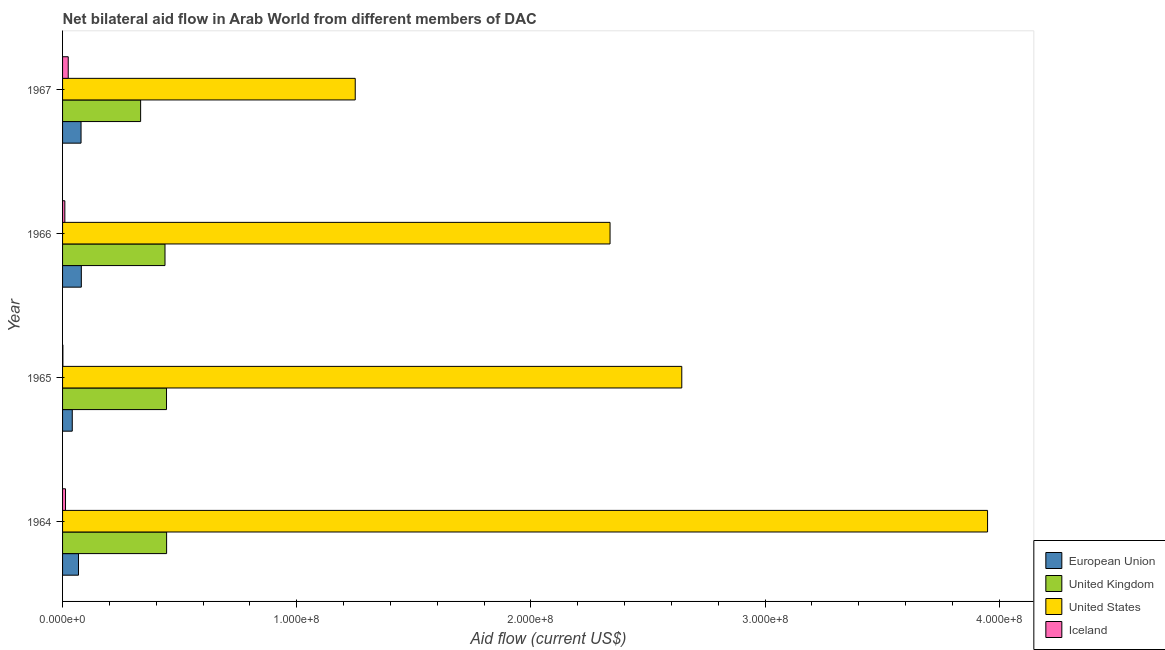How many groups of bars are there?
Ensure brevity in your answer.  4. How many bars are there on the 1st tick from the top?
Your answer should be very brief. 4. How many bars are there on the 2nd tick from the bottom?
Offer a very short reply. 4. What is the label of the 1st group of bars from the top?
Your answer should be compact. 1967. What is the amount of aid given by us in 1967?
Your answer should be compact. 1.25e+08. Across all years, what is the maximum amount of aid given by eu?
Provide a short and direct response. 8.01e+06. Across all years, what is the minimum amount of aid given by uk?
Offer a very short reply. 3.33e+07. In which year was the amount of aid given by iceland maximum?
Make the answer very short. 1967. In which year was the amount of aid given by iceland minimum?
Give a very brief answer. 1965. What is the total amount of aid given by eu in the graph?
Offer a terse response. 2.68e+07. What is the difference between the amount of aid given by uk in 1964 and that in 1967?
Offer a terse response. 1.11e+07. What is the difference between the amount of aid given by iceland in 1965 and the amount of aid given by eu in 1964?
Keep it short and to the point. -6.66e+06. What is the average amount of aid given by uk per year?
Provide a short and direct response. 4.15e+07. In the year 1967, what is the difference between the amount of aid given by eu and amount of aid given by us?
Offer a very short reply. -1.17e+08. In how many years, is the amount of aid given by us greater than 60000000 US$?
Your response must be concise. 4. What is the ratio of the amount of aid given by eu in 1965 to that in 1967?
Ensure brevity in your answer.  0.53. Is the amount of aid given by uk in 1964 less than that in 1965?
Your response must be concise. No. Is the difference between the amount of aid given by eu in 1964 and 1965 greater than the difference between the amount of aid given by uk in 1964 and 1965?
Keep it short and to the point. Yes. What is the difference between the highest and the second highest amount of aid given by us?
Ensure brevity in your answer.  1.31e+08. What is the difference between the highest and the lowest amount of aid given by iceland?
Your answer should be very brief. 2.28e+06. In how many years, is the amount of aid given by iceland greater than the average amount of aid given by iceland taken over all years?
Ensure brevity in your answer.  2. Is it the case that in every year, the sum of the amount of aid given by us and amount of aid given by uk is greater than the sum of amount of aid given by eu and amount of aid given by iceland?
Your answer should be compact. Yes. What does the 1st bar from the top in 1965 represents?
Provide a succinct answer. Iceland. How many bars are there?
Offer a terse response. 16. How many years are there in the graph?
Keep it short and to the point. 4. What is the difference between two consecutive major ticks on the X-axis?
Your answer should be very brief. 1.00e+08. Are the values on the major ticks of X-axis written in scientific E-notation?
Provide a succinct answer. Yes. Does the graph contain any zero values?
Offer a very short reply. No. Where does the legend appear in the graph?
Offer a terse response. Bottom right. How are the legend labels stacked?
Provide a short and direct response. Vertical. What is the title of the graph?
Provide a succinct answer. Net bilateral aid flow in Arab World from different members of DAC. What is the label or title of the Y-axis?
Give a very brief answer. Year. What is the Aid flow (current US$) of European Union in 1964?
Keep it short and to the point. 6.80e+06. What is the Aid flow (current US$) of United Kingdom in 1964?
Your answer should be compact. 4.44e+07. What is the Aid flow (current US$) in United States in 1964?
Make the answer very short. 3.95e+08. What is the Aid flow (current US$) in Iceland in 1964?
Offer a terse response. 1.26e+06. What is the Aid flow (current US$) in European Union in 1965?
Offer a terse response. 4.14e+06. What is the Aid flow (current US$) of United Kingdom in 1965?
Offer a very short reply. 4.44e+07. What is the Aid flow (current US$) in United States in 1965?
Your response must be concise. 2.64e+08. What is the Aid flow (current US$) of European Union in 1966?
Make the answer very short. 8.01e+06. What is the Aid flow (current US$) of United Kingdom in 1966?
Offer a terse response. 4.37e+07. What is the Aid flow (current US$) in United States in 1966?
Provide a short and direct response. 2.34e+08. What is the Aid flow (current US$) of Iceland in 1966?
Make the answer very short. 9.70e+05. What is the Aid flow (current US$) in European Union in 1967?
Your answer should be compact. 7.89e+06. What is the Aid flow (current US$) in United Kingdom in 1967?
Offer a very short reply. 3.33e+07. What is the Aid flow (current US$) in United States in 1967?
Make the answer very short. 1.25e+08. What is the Aid flow (current US$) of Iceland in 1967?
Provide a short and direct response. 2.42e+06. Across all years, what is the maximum Aid flow (current US$) of European Union?
Offer a very short reply. 8.01e+06. Across all years, what is the maximum Aid flow (current US$) in United Kingdom?
Give a very brief answer. 4.44e+07. Across all years, what is the maximum Aid flow (current US$) in United States?
Offer a very short reply. 3.95e+08. Across all years, what is the maximum Aid flow (current US$) of Iceland?
Offer a terse response. 2.42e+06. Across all years, what is the minimum Aid flow (current US$) in European Union?
Your response must be concise. 4.14e+06. Across all years, what is the minimum Aid flow (current US$) of United Kingdom?
Ensure brevity in your answer.  3.33e+07. Across all years, what is the minimum Aid flow (current US$) in United States?
Offer a very short reply. 1.25e+08. Across all years, what is the minimum Aid flow (current US$) in Iceland?
Your response must be concise. 1.40e+05. What is the total Aid flow (current US$) of European Union in the graph?
Give a very brief answer. 2.68e+07. What is the total Aid flow (current US$) of United Kingdom in the graph?
Your answer should be very brief. 1.66e+08. What is the total Aid flow (current US$) in United States in the graph?
Provide a short and direct response. 1.02e+09. What is the total Aid flow (current US$) in Iceland in the graph?
Your answer should be very brief. 4.79e+06. What is the difference between the Aid flow (current US$) in European Union in 1964 and that in 1965?
Provide a succinct answer. 2.66e+06. What is the difference between the Aid flow (current US$) of United States in 1964 and that in 1965?
Provide a short and direct response. 1.31e+08. What is the difference between the Aid flow (current US$) in Iceland in 1964 and that in 1965?
Offer a very short reply. 1.12e+06. What is the difference between the Aid flow (current US$) in European Union in 1964 and that in 1966?
Give a very brief answer. -1.21e+06. What is the difference between the Aid flow (current US$) in United Kingdom in 1964 and that in 1966?
Make the answer very short. 6.90e+05. What is the difference between the Aid flow (current US$) of United States in 1964 and that in 1966?
Provide a short and direct response. 1.61e+08. What is the difference between the Aid flow (current US$) of European Union in 1964 and that in 1967?
Provide a short and direct response. -1.09e+06. What is the difference between the Aid flow (current US$) in United Kingdom in 1964 and that in 1967?
Offer a terse response. 1.11e+07. What is the difference between the Aid flow (current US$) in United States in 1964 and that in 1967?
Ensure brevity in your answer.  2.70e+08. What is the difference between the Aid flow (current US$) of Iceland in 1964 and that in 1967?
Provide a short and direct response. -1.16e+06. What is the difference between the Aid flow (current US$) in European Union in 1965 and that in 1966?
Give a very brief answer. -3.87e+06. What is the difference between the Aid flow (current US$) in United Kingdom in 1965 and that in 1966?
Offer a very short reply. 6.50e+05. What is the difference between the Aid flow (current US$) of United States in 1965 and that in 1966?
Your answer should be very brief. 3.06e+07. What is the difference between the Aid flow (current US$) in Iceland in 1965 and that in 1966?
Your response must be concise. -8.30e+05. What is the difference between the Aid flow (current US$) in European Union in 1965 and that in 1967?
Ensure brevity in your answer.  -3.75e+06. What is the difference between the Aid flow (current US$) in United Kingdom in 1965 and that in 1967?
Keep it short and to the point. 1.11e+07. What is the difference between the Aid flow (current US$) in United States in 1965 and that in 1967?
Your response must be concise. 1.39e+08. What is the difference between the Aid flow (current US$) in Iceland in 1965 and that in 1967?
Offer a terse response. -2.28e+06. What is the difference between the Aid flow (current US$) in United Kingdom in 1966 and that in 1967?
Provide a succinct answer. 1.04e+07. What is the difference between the Aid flow (current US$) in United States in 1966 and that in 1967?
Your answer should be very brief. 1.09e+08. What is the difference between the Aid flow (current US$) of Iceland in 1966 and that in 1967?
Give a very brief answer. -1.45e+06. What is the difference between the Aid flow (current US$) of European Union in 1964 and the Aid flow (current US$) of United Kingdom in 1965?
Ensure brevity in your answer.  -3.76e+07. What is the difference between the Aid flow (current US$) in European Union in 1964 and the Aid flow (current US$) in United States in 1965?
Keep it short and to the point. -2.58e+08. What is the difference between the Aid flow (current US$) of European Union in 1964 and the Aid flow (current US$) of Iceland in 1965?
Make the answer very short. 6.66e+06. What is the difference between the Aid flow (current US$) of United Kingdom in 1964 and the Aid flow (current US$) of United States in 1965?
Offer a terse response. -2.20e+08. What is the difference between the Aid flow (current US$) in United Kingdom in 1964 and the Aid flow (current US$) in Iceland in 1965?
Your answer should be compact. 4.43e+07. What is the difference between the Aid flow (current US$) of United States in 1964 and the Aid flow (current US$) of Iceland in 1965?
Provide a short and direct response. 3.95e+08. What is the difference between the Aid flow (current US$) in European Union in 1964 and the Aid flow (current US$) in United Kingdom in 1966?
Provide a short and direct response. -3.69e+07. What is the difference between the Aid flow (current US$) in European Union in 1964 and the Aid flow (current US$) in United States in 1966?
Your answer should be compact. -2.27e+08. What is the difference between the Aid flow (current US$) of European Union in 1964 and the Aid flow (current US$) of Iceland in 1966?
Offer a terse response. 5.83e+06. What is the difference between the Aid flow (current US$) of United Kingdom in 1964 and the Aid flow (current US$) of United States in 1966?
Your response must be concise. -1.89e+08. What is the difference between the Aid flow (current US$) in United Kingdom in 1964 and the Aid flow (current US$) in Iceland in 1966?
Ensure brevity in your answer.  4.35e+07. What is the difference between the Aid flow (current US$) of United States in 1964 and the Aid flow (current US$) of Iceland in 1966?
Provide a succinct answer. 3.94e+08. What is the difference between the Aid flow (current US$) in European Union in 1964 and the Aid flow (current US$) in United Kingdom in 1967?
Your answer should be compact. -2.65e+07. What is the difference between the Aid flow (current US$) of European Union in 1964 and the Aid flow (current US$) of United States in 1967?
Offer a terse response. -1.18e+08. What is the difference between the Aid flow (current US$) in European Union in 1964 and the Aid flow (current US$) in Iceland in 1967?
Provide a short and direct response. 4.38e+06. What is the difference between the Aid flow (current US$) in United Kingdom in 1964 and the Aid flow (current US$) in United States in 1967?
Give a very brief answer. -8.06e+07. What is the difference between the Aid flow (current US$) of United Kingdom in 1964 and the Aid flow (current US$) of Iceland in 1967?
Your answer should be compact. 4.20e+07. What is the difference between the Aid flow (current US$) in United States in 1964 and the Aid flow (current US$) in Iceland in 1967?
Provide a short and direct response. 3.93e+08. What is the difference between the Aid flow (current US$) of European Union in 1965 and the Aid flow (current US$) of United Kingdom in 1966?
Your answer should be compact. -3.96e+07. What is the difference between the Aid flow (current US$) of European Union in 1965 and the Aid flow (current US$) of United States in 1966?
Provide a succinct answer. -2.30e+08. What is the difference between the Aid flow (current US$) of European Union in 1965 and the Aid flow (current US$) of Iceland in 1966?
Ensure brevity in your answer.  3.17e+06. What is the difference between the Aid flow (current US$) of United Kingdom in 1965 and the Aid flow (current US$) of United States in 1966?
Provide a short and direct response. -1.89e+08. What is the difference between the Aid flow (current US$) in United Kingdom in 1965 and the Aid flow (current US$) in Iceland in 1966?
Provide a short and direct response. 4.34e+07. What is the difference between the Aid flow (current US$) of United States in 1965 and the Aid flow (current US$) of Iceland in 1966?
Offer a very short reply. 2.63e+08. What is the difference between the Aid flow (current US$) of European Union in 1965 and the Aid flow (current US$) of United Kingdom in 1967?
Offer a terse response. -2.92e+07. What is the difference between the Aid flow (current US$) of European Union in 1965 and the Aid flow (current US$) of United States in 1967?
Make the answer very short. -1.21e+08. What is the difference between the Aid flow (current US$) in European Union in 1965 and the Aid flow (current US$) in Iceland in 1967?
Ensure brevity in your answer.  1.72e+06. What is the difference between the Aid flow (current US$) of United Kingdom in 1965 and the Aid flow (current US$) of United States in 1967?
Provide a short and direct response. -8.06e+07. What is the difference between the Aid flow (current US$) of United Kingdom in 1965 and the Aid flow (current US$) of Iceland in 1967?
Your response must be concise. 4.20e+07. What is the difference between the Aid flow (current US$) of United States in 1965 and the Aid flow (current US$) of Iceland in 1967?
Keep it short and to the point. 2.62e+08. What is the difference between the Aid flow (current US$) in European Union in 1966 and the Aid flow (current US$) in United Kingdom in 1967?
Your answer should be very brief. -2.53e+07. What is the difference between the Aid flow (current US$) in European Union in 1966 and the Aid flow (current US$) in United States in 1967?
Keep it short and to the point. -1.17e+08. What is the difference between the Aid flow (current US$) of European Union in 1966 and the Aid flow (current US$) of Iceland in 1967?
Your answer should be compact. 5.59e+06. What is the difference between the Aid flow (current US$) in United Kingdom in 1966 and the Aid flow (current US$) in United States in 1967?
Your answer should be very brief. -8.12e+07. What is the difference between the Aid flow (current US$) in United Kingdom in 1966 and the Aid flow (current US$) in Iceland in 1967?
Make the answer very short. 4.13e+07. What is the difference between the Aid flow (current US$) of United States in 1966 and the Aid flow (current US$) of Iceland in 1967?
Your response must be concise. 2.31e+08. What is the average Aid flow (current US$) of European Union per year?
Offer a terse response. 6.71e+06. What is the average Aid flow (current US$) of United Kingdom per year?
Provide a short and direct response. 4.15e+07. What is the average Aid flow (current US$) of United States per year?
Provide a short and direct response. 2.55e+08. What is the average Aid flow (current US$) in Iceland per year?
Your response must be concise. 1.20e+06. In the year 1964, what is the difference between the Aid flow (current US$) in European Union and Aid flow (current US$) in United Kingdom?
Keep it short and to the point. -3.76e+07. In the year 1964, what is the difference between the Aid flow (current US$) of European Union and Aid flow (current US$) of United States?
Give a very brief answer. -3.88e+08. In the year 1964, what is the difference between the Aid flow (current US$) of European Union and Aid flow (current US$) of Iceland?
Your answer should be very brief. 5.54e+06. In the year 1964, what is the difference between the Aid flow (current US$) in United Kingdom and Aid flow (current US$) in United States?
Provide a short and direct response. -3.51e+08. In the year 1964, what is the difference between the Aid flow (current US$) of United Kingdom and Aid flow (current US$) of Iceland?
Offer a terse response. 4.32e+07. In the year 1964, what is the difference between the Aid flow (current US$) of United States and Aid flow (current US$) of Iceland?
Offer a very short reply. 3.94e+08. In the year 1965, what is the difference between the Aid flow (current US$) of European Union and Aid flow (current US$) of United Kingdom?
Your answer should be compact. -4.02e+07. In the year 1965, what is the difference between the Aid flow (current US$) in European Union and Aid flow (current US$) in United States?
Give a very brief answer. -2.60e+08. In the year 1965, what is the difference between the Aid flow (current US$) in United Kingdom and Aid flow (current US$) in United States?
Offer a very short reply. -2.20e+08. In the year 1965, what is the difference between the Aid flow (current US$) of United Kingdom and Aid flow (current US$) of Iceland?
Make the answer very short. 4.42e+07. In the year 1965, what is the difference between the Aid flow (current US$) of United States and Aid flow (current US$) of Iceland?
Ensure brevity in your answer.  2.64e+08. In the year 1966, what is the difference between the Aid flow (current US$) in European Union and Aid flow (current US$) in United Kingdom?
Offer a very short reply. -3.57e+07. In the year 1966, what is the difference between the Aid flow (current US$) in European Union and Aid flow (current US$) in United States?
Offer a very short reply. -2.26e+08. In the year 1966, what is the difference between the Aid flow (current US$) in European Union and Aid flow (current US$) in Iceland?
Keep it short and to the point. 7.04e+06. In the year 1966, what is the difference between the Aid flow (current US$) in United Kingdom and Aid flow (current US$) in United States?
Your answer should be very brief. -1.90e+08. In the year 1966, what is the difference between the Aid flow (current US$) of United Kingdom and Aid flow (current US$) of Iceland?
Your answer should be very brief. 4.28e+07. In the year 1966, what is the difference between the Aid flow (current US$) of United States and Aid flow (current US$) of Iceland?
Provide a succinct answer. 2.33e+08. In the year 1967, what is the difference between the Aid flow (current US$) in European Union and Aid flow (current US$) in United Kingdom?
Give a very brief answer. -2.54e+07. In the year 1967, what is the difference between the Aid flow (current US$) of European Union and Aid flow (current US$) of United States?
Provide a succinct answer. -1.17e+08. In the year 1967, what is the difference between the Aid flow (current US$) of European Union and Aid flow (current US$) of Iceland?
Make the answer very short. 5.47e+06. In the year 1967, what is the difference between the Aid flow (current US$) in United Kingdom and Aid flow (current US$) in United States?
Ensure brevity in your answer.  -9.16e+07. In the year 1967, what is the difference between the Aid flow (current US$) in United Kingdom and Aid flow (current US$) in Iceland?
Give a very brief answer. 3.09e+07. In the year 1967, what is the difference between the Aid flow (current US$) in United States and Aid flow (current US$) in Iceland?
Give a very brief answer. 1.23e+08. What is the ratio of the Aid flow (current US$) of European Union in 1964 to that in 1965?
Your answer should be compact. 1.64. What is the ratio of the Aid flow (current US$) of United States in 1964 to that in 1965?
Your answer should be compact. 1.49. What is the ratio of the Aid flow (current US$) in European Union in 1964 to that in 1966?
Provide a short and direct response. 0.85. What is the ratio of the Aid flow (current US$) in United Kingdom in 1964 to that in 1966?
Keep it short and to the point. 1.02. What is the ratio of the Aid flow (current US$) of United States in 1964 to that in 1966?
Provide a short and direct response. 1.69. What is the ratio of the Aid flow (current US$) of Iceland in 1964 to that in 1966?
Keep it short and to the point. 1.3. What is the ratio of the Aid flow (current US$) in European Union in 1964 to that in 1967?
Ensure brevity in your answer.  0.86. What is the ratio of the Aid flow (current US$) of United Kingdom in 1964 to that in 1967?
Ensure brevity in your answer.  1.33. What is the ratio of the Aid flow (current US$) in United States in 1964 to that in 1967?
Provide a succinct answer. 3.16. What is the ratio of the Aid flow (current US$) of Iceland in 1964 to that in 1967?
Offer a very short reply. 0.52. What is the ratio of the Aid flow (current US$) of European Union in 1965 to that in 1966?
Your answer should be very brief. 0.52. What is the ratio of the Aid flow (current US$) of United Kingdom in 1965 to that in 1966?
Keep it short and to the point. 1.01. What is the ratio of the Aid flow (current US$) of United States in 1965 to that in 1966?
Your answer should be compact. 1.13. What is the ratio of the Aid flow (current US$) in Iceland in 1965 to that in 1966?
Give a very brief answer. 0.14. What is the ratio of the Aid flow (current US$) of European Union in 1965 to that in 1967?
Keep it short and to the point. 0.52. What is the ratio of the Aid flow (current US$) of United Kingdom in 1965 to that in 1967?
Ensure brevity in your answer.  1.33. What is the ratio of the Aid flow (current US$) in United States in 1965 to that in 1967?
Offer a very short reply. 2.12. What is the ratio of the Aid flow (current US$) of Iceland in 1965 to that in 1967?
Give a very brief answer. 0.06. What is the ratio of the Aid flow (current US$) in European Union in 1966 to that in 1967?
Your answer should be very brief. 1.02. What is the ratio of the Aid flow (current US$) in United Kingdom in 1966 to that in 1967?
Provide a short and direct response. 1.31. What is the ratio of the Aid flow (current US$) of United States in 1966 to that in 1967?
Ensure brevity in your answer.  1.87. What is the ratio of the Aid flow (current US$) of Iceland in 1966 to that in 1967?
Make the answer very short. 0.4. What is the difference between the highest and the second highest Aid flow (current US$) of United States?
Give a very brief answer. 1.31e+08. What is the difference between the highest and the second highest Aid flow (current US$) of Iceland?
Provide a succinct answer. 1.16e+06. What is the difference between the highest and the lowest Aid flow (current US$) in European Union?
Your answer should be compact. 3.87e+06. What is the difference between the highest and the lowest Aid flow (current US$) in United Kingdom?
Make the answer very short. 1.11e+07. What is the difference between the highest and the lowest Aid flow (current US$) in United States?
Your answer should be compact. 2.70e+08. What is the difference between the highest and the lowest Aid flow (current US$) of Iceland?
Ensure brevity in your answer.  2.28e+06. 